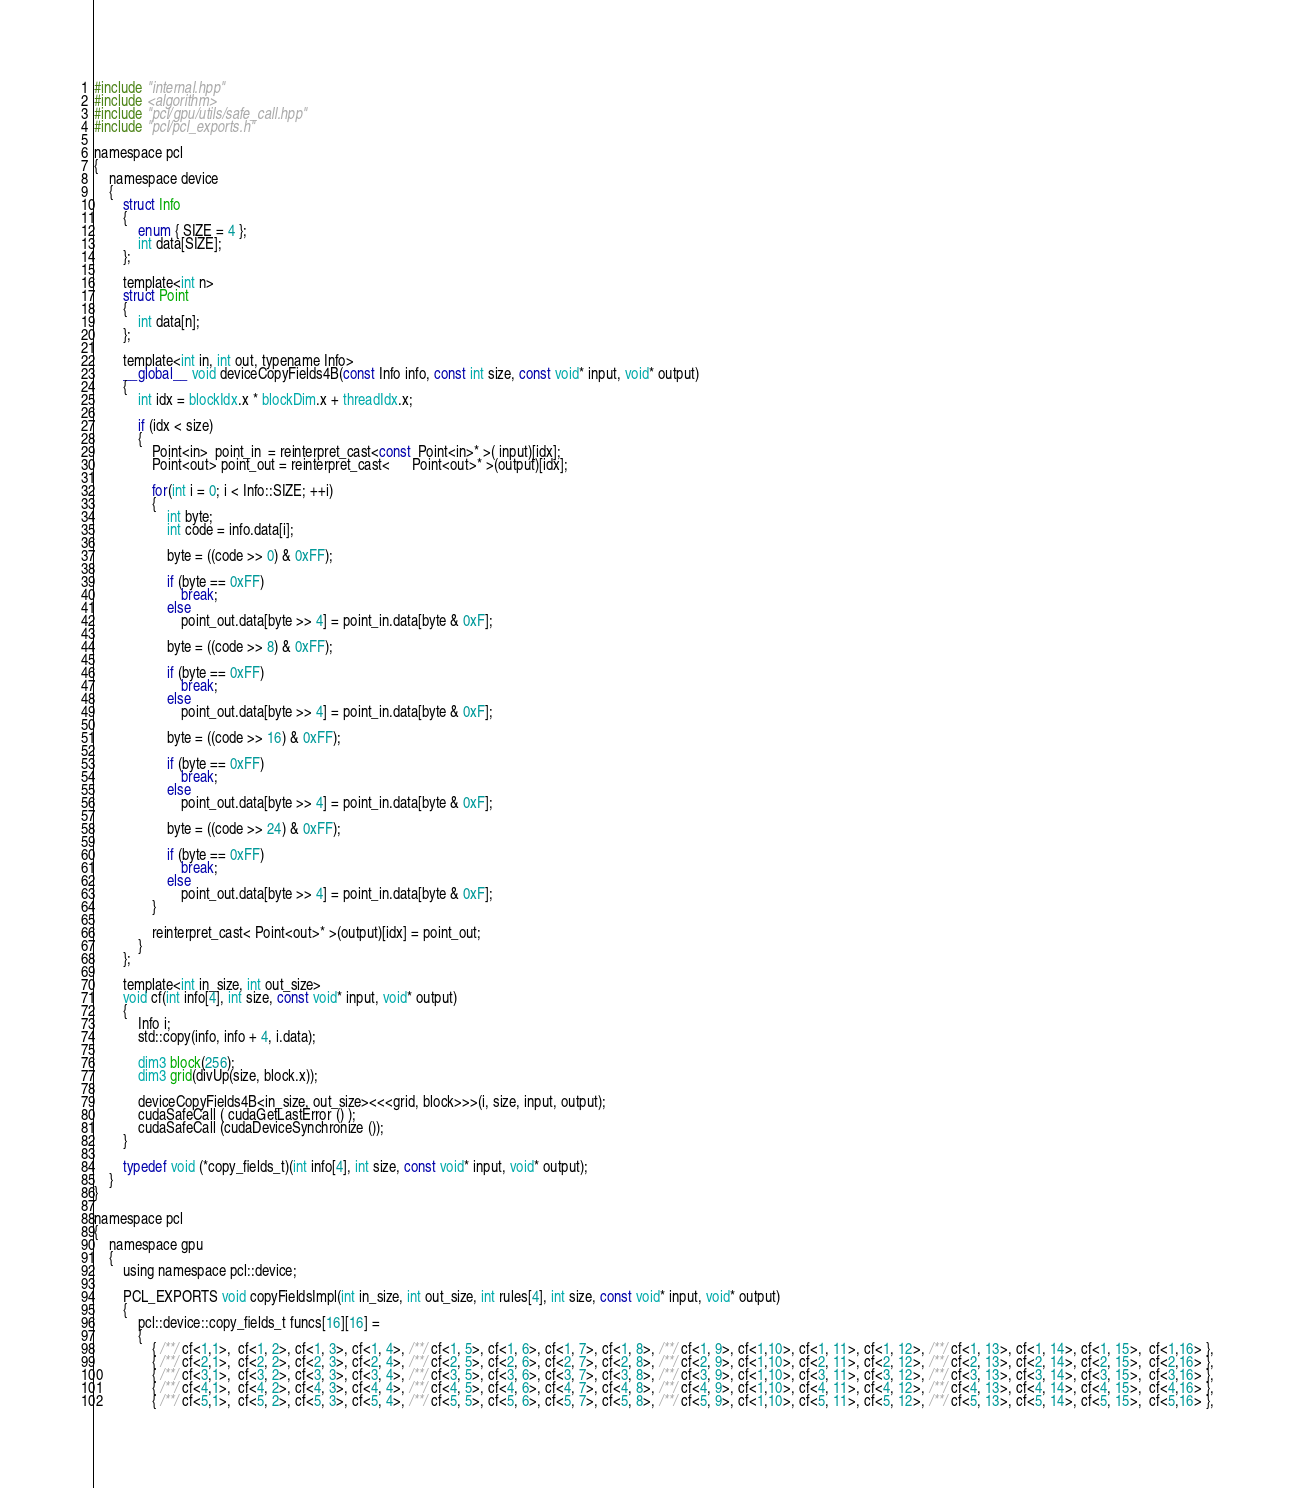<code> <loc_0><loc_0><loc_500><loc_500><_Cuda_>#include "internal.hpp"
#include <algorithm>
#include "pcl/gpu/utils/safe_call.hpp"
#include "pcl/pcl_exports.h"

namespace pcl
{
    namespace device
    {
        struct Info
        {
            enum { SIZE = 4 };
            int data[SIZE];
        };

        template<int n>
        struct Point
        {
            int data[n];
        };

        template<int in, int out, typename Info>
        __global__ void deviceCopyFields4B(const Info info, const int size, const void* input, void* output)
        {
            int idx = blockIdx.x * blockDim.x + threadIdx.x;

            if (idx < size)
            {
                Point<in>  point_in  = reinterpret_cast<const  Point<in>* >( input)[idx];
                Point<out> point_out = reinterpret_cast<      Point<out>* >(output)[idx];

                for(int i = 0; i < Info::SIZE; ++i)
                {
                    int byte;
                    int code = info.data[i];

                    byte = ((code >> 0) & 0xFF);

                    if (byte == 0xFF)
                        break;
                    else
                        point_out.data[byte >> 4] = point_in.data[byte & 0xF];

                    byte = ((code >> 8) & 0xFF);

                    if (byte == 0xFF)
                        break;
                    else
                        point_out.data[byte >> 4] = point_in.data[byte & 0xF];

                    byte = ((code >> 16) & 0xFF);

                    if (byte == 0xFF)
                        break;
                    else
                        point_out.data[byte >> 4] = point_in.data[byte & 0xF];

                    byte = ((code >> 24) & 0xFF);

                    if (byte == 0xFF)
                        break;
                    else
                        point_out.data[byte >> 4] = point_in.data[byte & 0xF];
                }

                reinterpret_cast< Point<out>* >(output)[idx] = point_out;
            }
        };

        template<int in_size, int out_size>
        void cf(int info[4], int size, const void* input, void* output)
        {
            Info i;
            std::copy(info, info + 4, i.data);

            dim3 block(256);
            dim3 grid(divUp(size, block.x));

            deviceCopyFields4B<in_size, out_size><<<grid, block>>>(i, size, input, output);
            cudaSafeCall ( cudaGetLastError () );
            cudaSafeCall (cudaDeviceSynchronize ());
        }

        typedef void (*copy_fields_t)(int info[4], int size, const void* input, void* output);
    }
}

namespace pcl
{
    namespace gpu
    {
        using namespace pcl::device;

        PCL_EXPORTS void copyFieldsImpl(int in_size, int out_size, int rules[4], int size, const void* input, void* output)
        {
            pcl::device::copy_fields_t funcs[16][16] =
            {
                { /**/ cf<1,1>,  cf<1, 2>, cf<1, 3>, cf<1, 4>, /**/ cf<1, 5>, cf<1, 6>, cf<1, 7>, cf<1, 8>, /**/ cf<1, 9>, cf<1,10>, cf<1, 11>, cf<1, 12>, /**/ cf<1, 13>, cf<1, 14>, cf<1, 15>,  cf<1,16> },
                { /**/ cf<2,1>,  cf<2, 2>, cf<2, 3>, cf<2, 4>, /**/ cf<2, 5>, cf<2, 6>, cf<2, 7>, cf<2, 8>, /**/ cf<2, 9>, cf<1,10>, cf<2, 11>, cf<2, 12>, /**/ cf<2, 13>, cf<2, 14>, cf<2, 15>,  cf<2,16> },
                { /**/ cf<3,1>,  cf<3, 2>, cf<3, 3>, cf<3, 4>, /**/ cf<3, 5>, cf<3, 6>, cf<3, 7>, cf<3, 8>, /**/ cf<3, 9>, cf<1,10>, cf<3, 11>, cf<3, 12>, /**/ cf<3, 13>, cf<3, 14>, cf<3, 15>,  cf<3,16> },
                { /**/ cf<4,1>,  cf<4, 2>, cf<4, 3>, cf<4, 4>, /**/ cf<4, 5>, cf<4, 6>, cf<4, 7>, cf<4, 8>, /**/ cf<4, 9>, cf<1,10>, cf<4, 11>, cf<4, 12>, /**/ cf<4, 13>, cf<4, 14>, cf<4, 15>,  cf<4,16> },
                { /**/ cf<5,1>,  cf<5, 2>, cf<5, 3>, cf<5, 4>, /**/ cf<5, 5>, cf<5, 6>, cf<5, 7>, cf<5, 8>, /**/ cf<5, 9>, cf<1,10>, cf<5, 11>, cf<5, 12>, /**/ cf<5, 13>, cf<5, 14>, cf<5, 15>,  cf<5,16> },</code> 